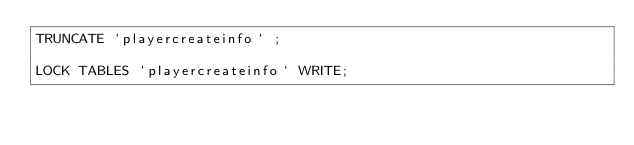Convert code to text. <code><loc_0><loc_0><loc_500><loc_500><_SQL_>TRUNCATE `playercreateinfo` ;

LOCK TABLES `playercreateinfo` WRITE;</code> 